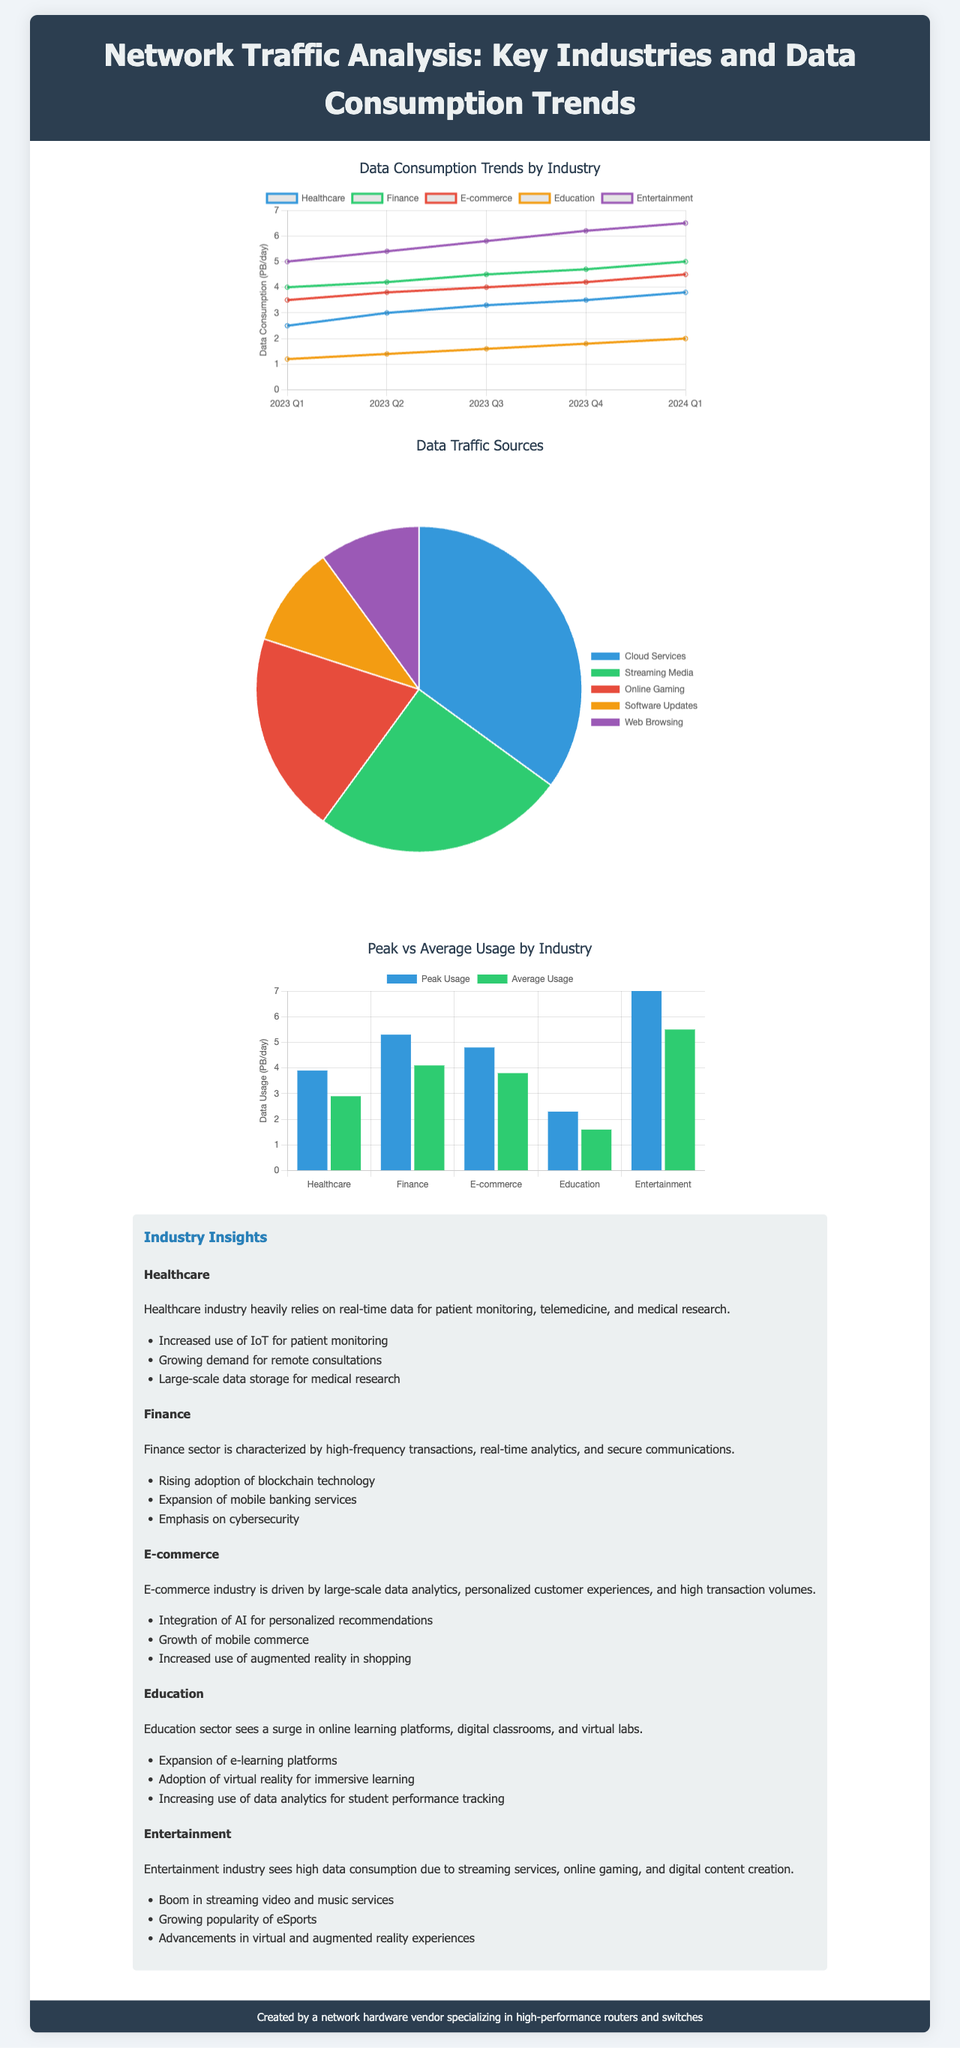What is the data consumption for the Entertainment industry in Q4 2023? The data consumption for the Entertainment industry in Q4 2023 is 6.2 PB/day, as shown in the line graph.
Answer: 6.2 PB/day Which industry has the highest average usage according to the stacked bar chart? The stacked bar chart compares peak vs average usage, highlighting Entertainment as having the highest average usage at 5.5 PB/day.
Answer: Entertainment What is the percentage of data traffic attributed to Cloud Services? The pie chart depicts that 35% of data traffic comes from Cloud Services.
Answer: 35% What is the overall trend of data consumption in the Healthcare industry from Q1 2023 to Q1 2024? The data consumption in the Healthcare industry shows a consistent increase, rising from 2.5 PB/day to 3.8 PB/day.
Answer: Increase What key trend is highlighted for the E-commerce industry? One key trend for the E-commerce industry is the integration of AI for personalized recommendations, as stated in the industry insights.
Answer: Integration of AI What is the total peak usage for the Finance industry? The peak usage for the Finance industry is shown as 5.3 PB/day in the stacked bar chart.
Answer: 5.3 PB/day Which industry demonstrates the highest data consumption in 2024 Q1? The line graph indicates Entertainment has the highest data consumption in 2024 Q1, at 6.5 PB/day.
Answer: Entertainment Which source contributes 10% to overall data traffic? The pie chart indicates that both Software Updates and Web Browsing contribute 10% each to the overall data traffic.
Answer: Software Updates and Web Browsing What is the average data usage for the Education industry? The average data usage for the Education industry is depicted in the bar chart as 1.6 PB/day.
Answer: 1.6 PB/day 